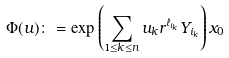<formula> <loc_0><loc_0><loc_500><loc_500>\Phi ( u ) \colon = \exp \left ( \sum _ { 1 \leq k \leq n } u _ { k } r ^ { \ell _ { i _ { k } } } Y _ { i _ { k } } \right ) x _ { 0 }</formula> 